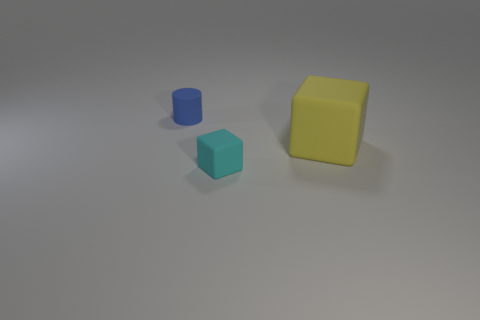Add 3 large red matte balls. How many objects exist? 6 Subtract all blocks. How many objects are left? 1 Subtract all yellow blocks. How many blocks are left? 1 Subtract 1 blue cylinders. How many objects are left? 2 Subtract 1 blocks. How many blocks are left? 1 Subtract all red cylinders. Subtract all red spheres. How many cylinders are left? 1 Subtract all gray cylinders. How many yellow blocks are left? 1 Subtract all tiny yellow metal things. Subtract all rubber blocks. How many objects are left? 1 Add 3 matte objects. How many matte objects are left? 6 Add 3 tiny cylinders. How many tiny cylinders exist? 4 